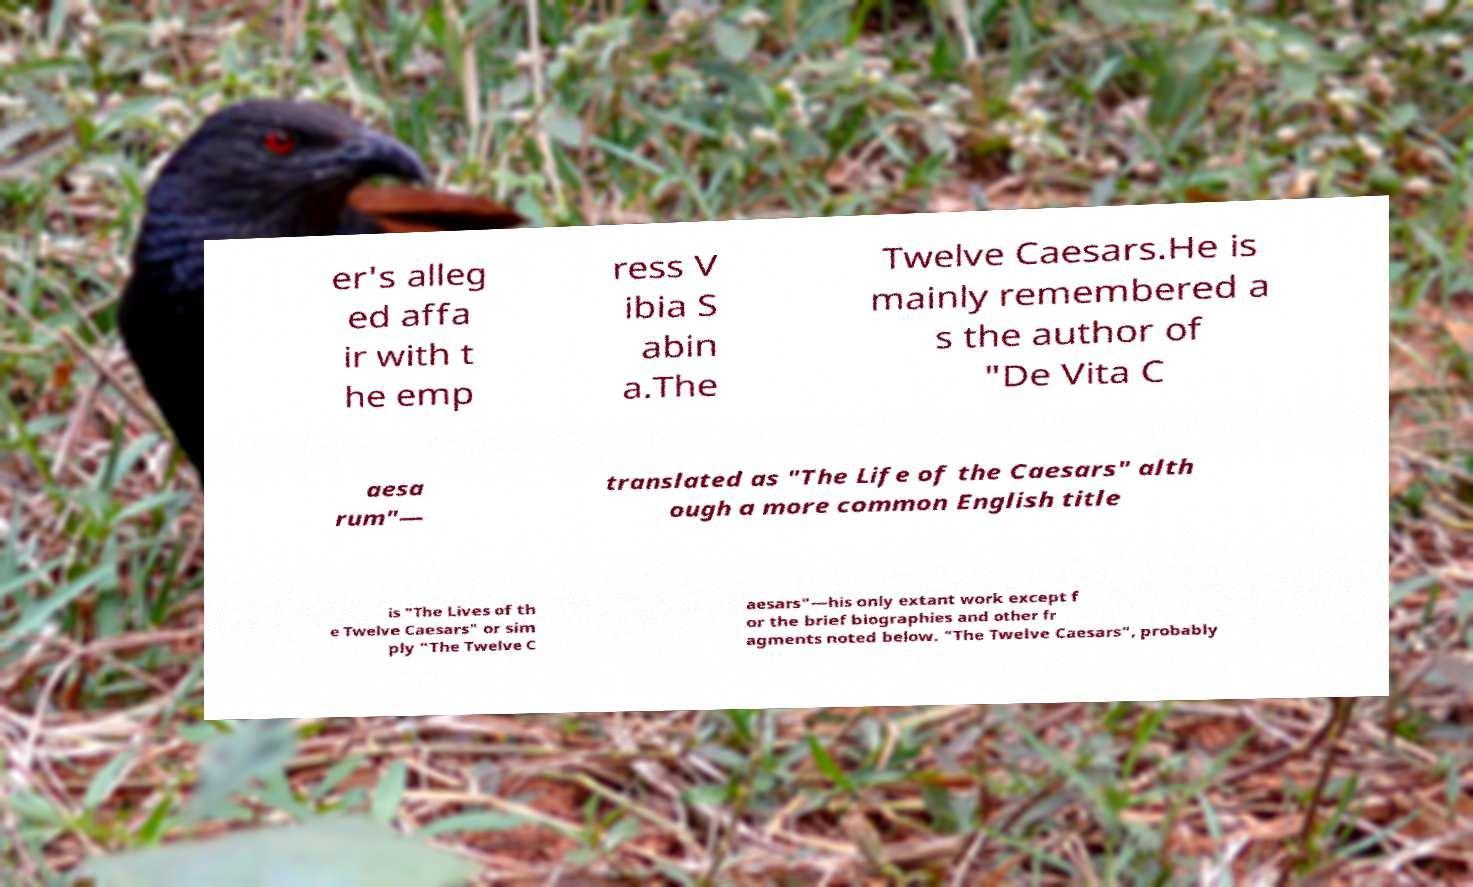Please read and relay the text visible in this image. What does it say? er's alleg ed affa ir with t he emp ress V ibia S abin a.The Twelve Caesars.He is mainly remembered a s the author of "De Vita C aesa rum"— translated as "The Life of the Caesars" alth ough a more common English title is "The Lives of th e Twelve Caesars" or sim ply "The Twelve C aesars"—his only extant work except f or the brief biographies and other fr agments noted below. "The Twelve Caesars", probably 